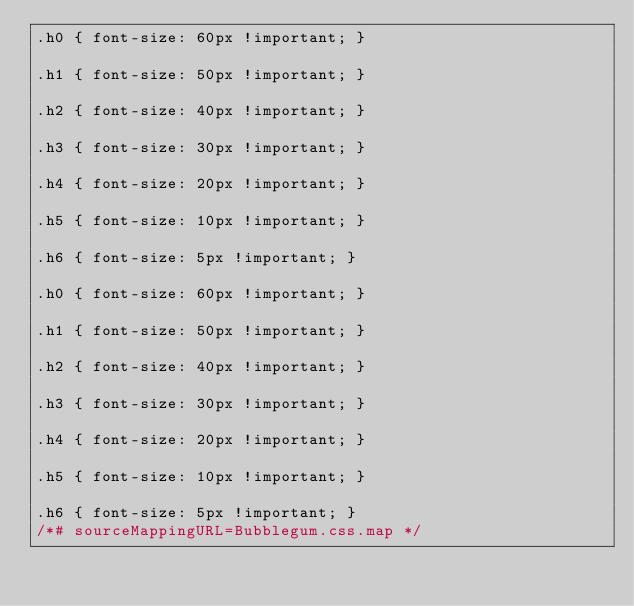Convert code to text. <code><loc_0><loc_0><loc_500><loc_500><_CSS_>.h0 { font-size: 60px !important; }

.h1 { font-size: 50px !important; }

.h2 { font-size: 40px !important; }

.h3 { font-size: 30px !important; }

.h4 { font-size: 20px !important; }

.h5 { font-size: 10px !important; }

.h6 { font-size: 5px !important; }

.h0 { font-size: 60px !important; }

.h1 { font-size: 50px !important; }

.h2 { font-size: 40px !important; }

.h3 { font-size: 30px !important; }

.h4 { font-size: 20px !important; }

.h5 { font-size: 10px !important; }

.h6 { font-size: 5px !important; }
/*# sourceMappingURL=Bubblegum.css.map */</code> 